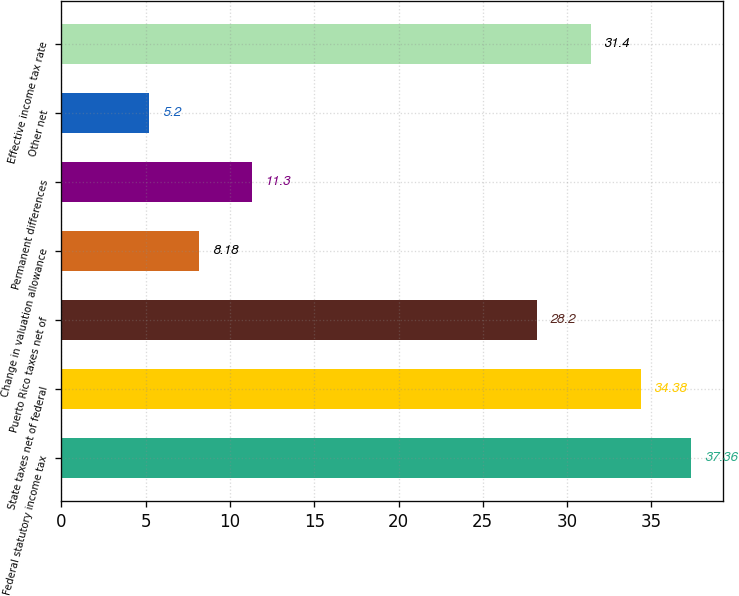<chart> <loc_0><loc_0><loc_500><loc_500><bar_chart><fcel>Federal statutory income tax<fcel>State taxes net of federal<fcel>Puerto Rico taxes net of<fcel>Change in valuation allowance<fcel>Permanent differences<fcel>Other net<fcel>Effective income tax rate<nl><fcel>37.36<fcel>34.38<fcel>28.2<fcel>8.18<fcel>11.3<fcel>5.2<fcel>31.4<nl></chart> 